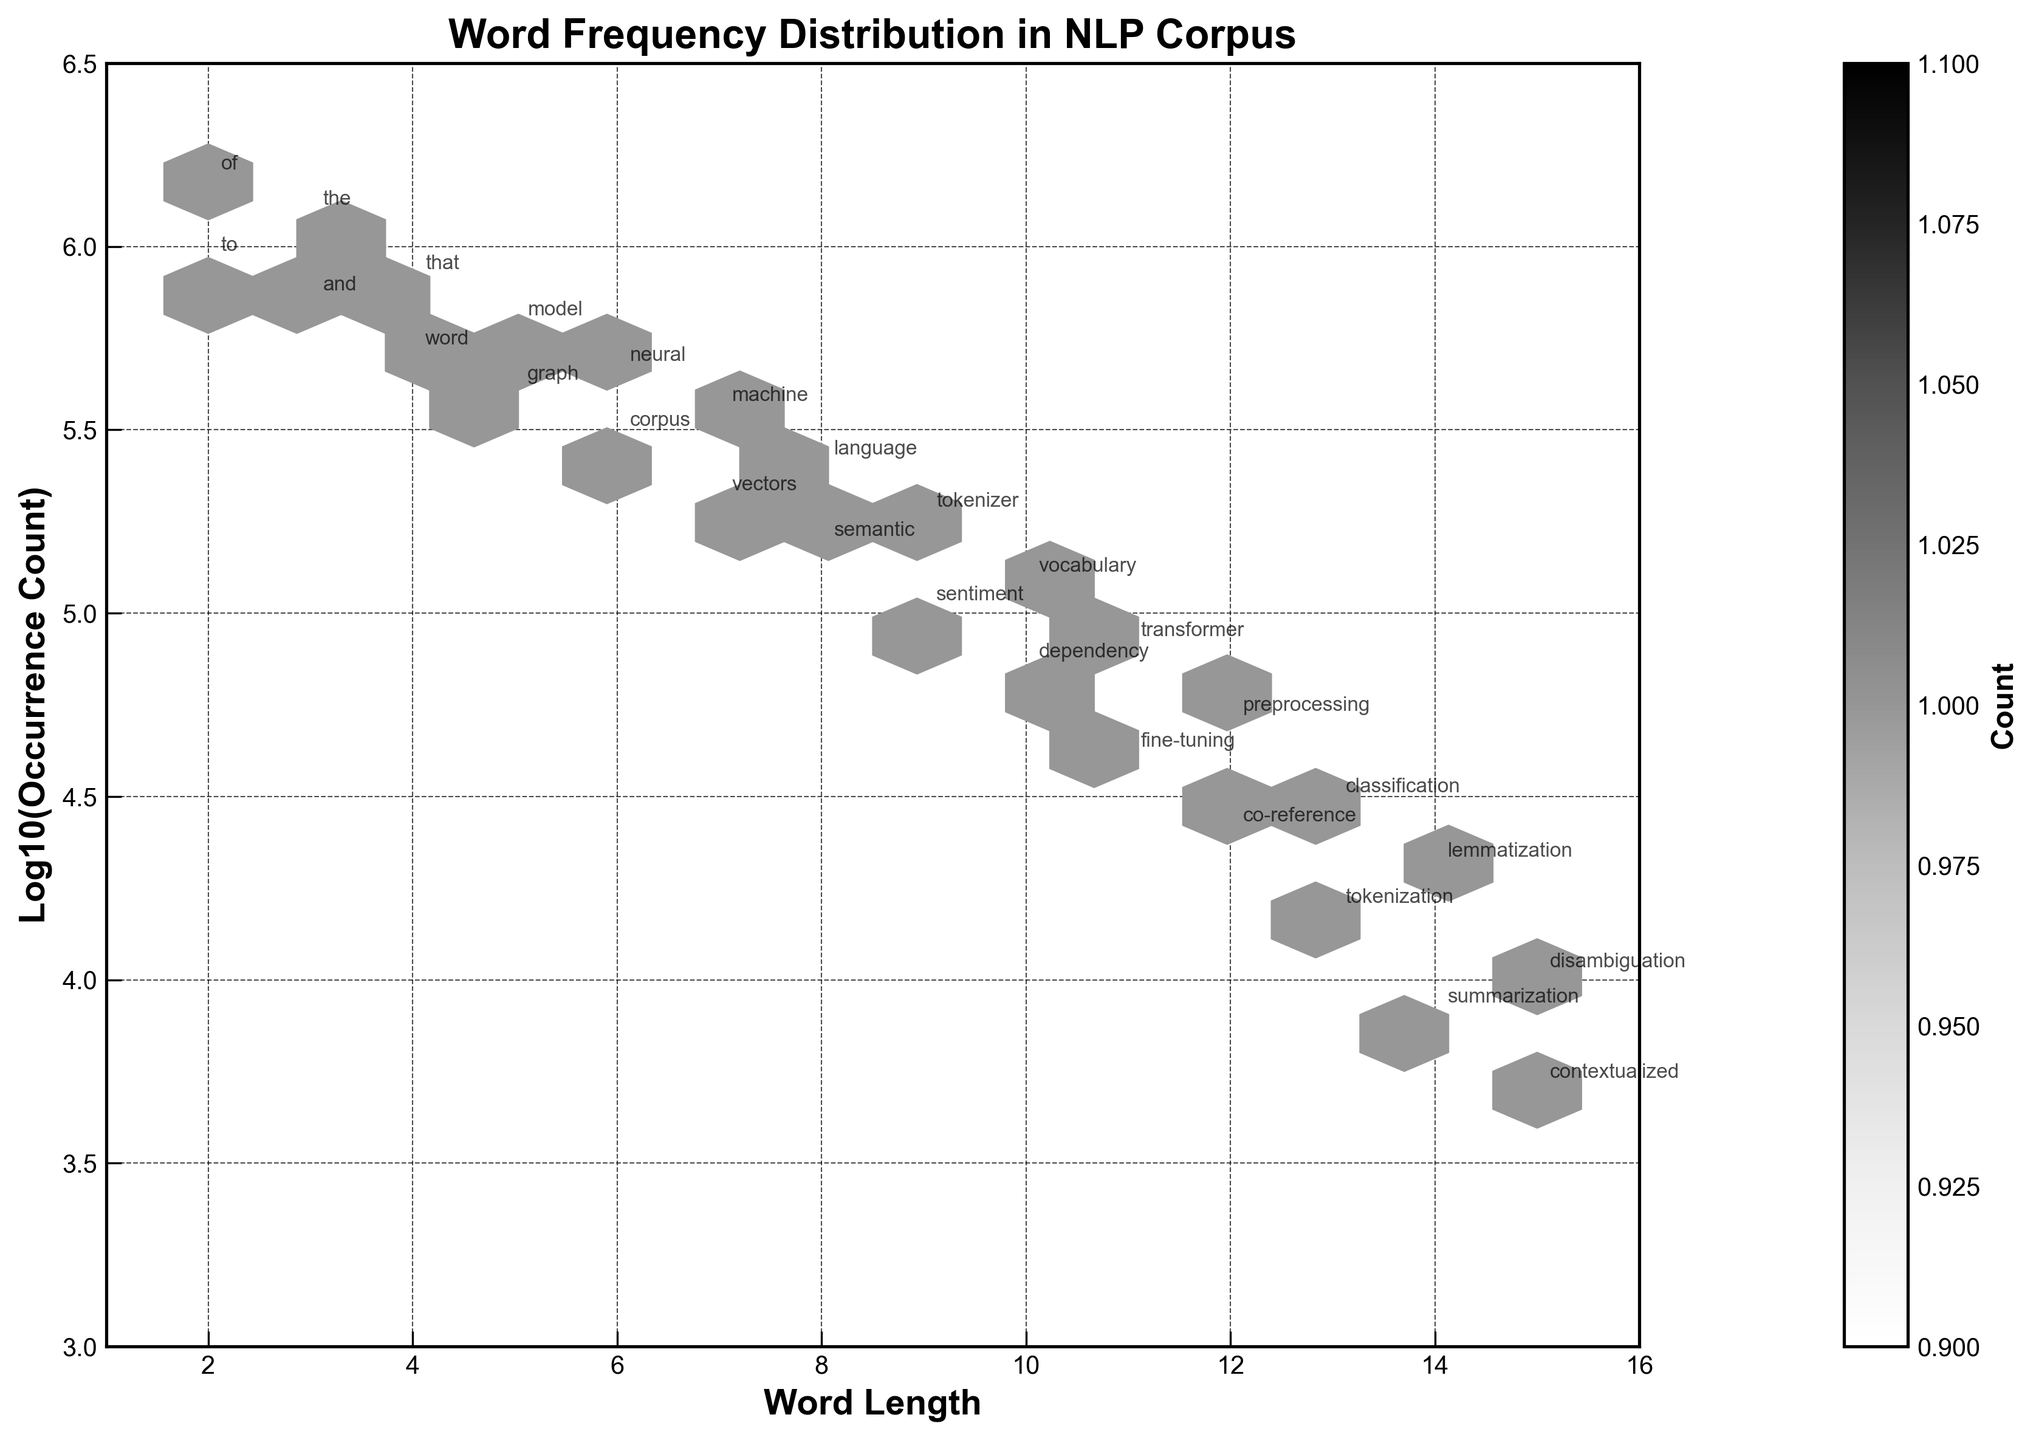What is the title of the hexbin plot? The title of the hexbin plot is located at the top of the figure and is usually larger and bolder than other text.
Answer: Word Frequency Distribution in NLP Corpus What are the labels on the x and y axes? The x-axis typically shows the variable being measured horizontally, and the y-axis shows the variable being measured vertically. In the figure, the x-axis label is 'Word Length' and the y-axis label is 'Log10(Occurrence Count)'.
Answer: Word Length and Log10(Occurrence Count) Which word has the highest occurrence count in the figure? To determine the word with the highest occurrence count, look at the y-axis (log10 scale) and find the highest value. The annotation at this point will provide the word.
Answer: 'of' In which range of word lengths do the most frequent words fall? The hexbin plot shows density by color intensity. The range with the darkest hexagons indicates the densest area.
Answer: 2-4 characters Which word length has the lowest frequency according to the plot? The lightest color hexagons represent areas with low frequency. Locate the least intense area across the word lengths.
Answer: 15 characters Compare the occurrence counts of words with lengths of 3 and 7 characters. The y-axis uses a log10 scale, so calculate 10^y to get the original occurrence counts for these word lengths. Compare the annotations ('the' and 'machine') for confirmation.
Answer: 3-character words have higher counts Which words are annotated on this plot with lengths between 9 and 13 characters? The annotations are placed next to the corresponding points. Identify all such labels falling within the 9 to 13 character range.
Answer: tokenizer, vocabulary, transformer, preprocessing, classification, lemmatization, disambiguation What is the count value (log scale) range displayed on the color bar? The color bar on the right of the plot shows the range of occurrence counts in a log scale. Identify its starting and ending values.
Answer: Approximately 3 to 6 Identify any trends in word popularity as word length increases. Observe the pattern of hexbin density and annotations across increasing word lengths. Trends are inferred from higher density regions and their annotations.
Answer: Popular words generally decrease as length increases 